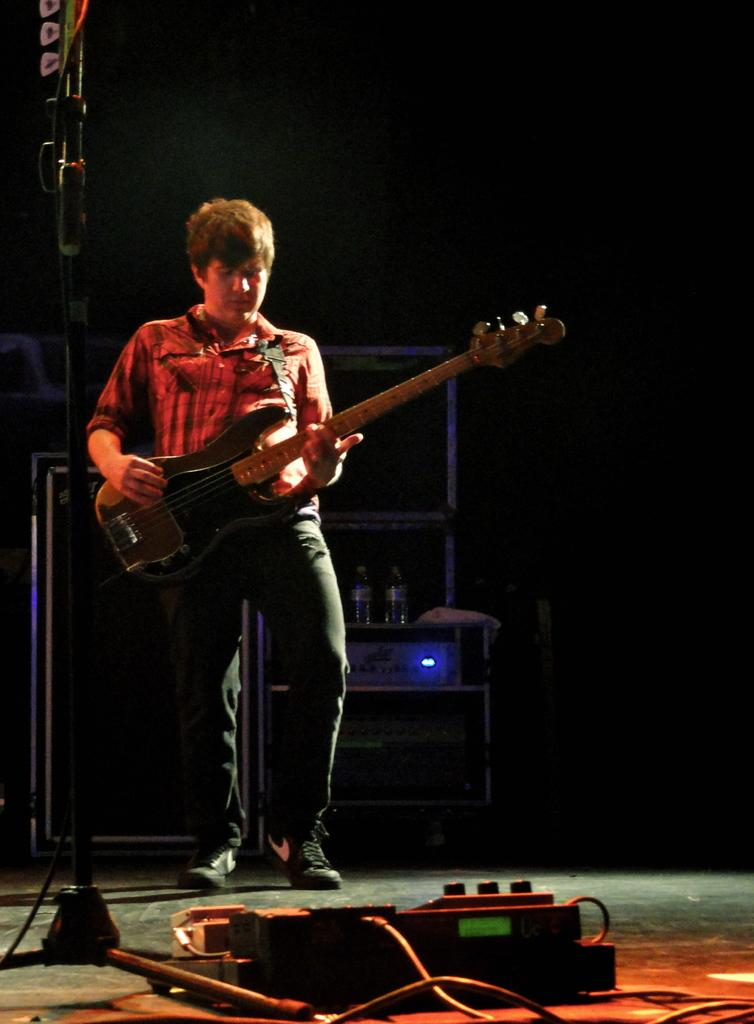What is the person in the image doing? The person is playing a guitar in the image. What can be seen on the left side of the image? There is a stand and a wire on the left side of the image. What is located at the bottom of the image? There is a machine at the bottom of the image. What objects can be seen in the background of the image? There are boxes, a bottle, and a speaker in the background of the image. Can you see the person's mother in the image? There is no mention of a mother or any other person in the image, only the person playing the guitar. How many feet are visible in the image? The image does not show any feet; it only shows the person playing the guitar and the surrounding objects. 